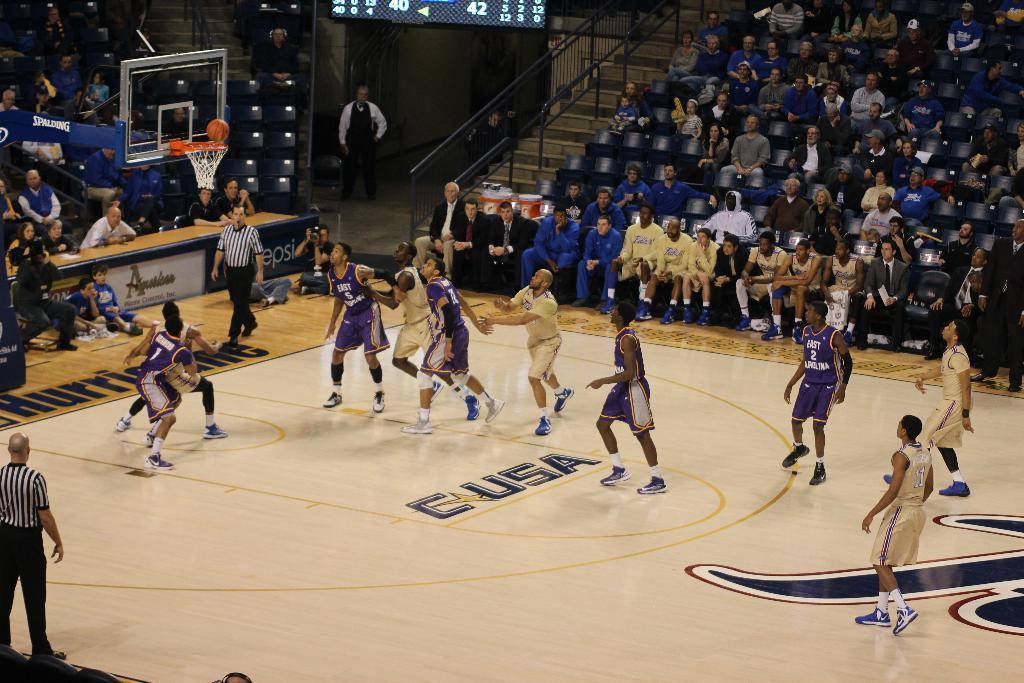In one or two sentences, can you explain what this image depicts? In this picture we can see group of people, few are seated on the chairs, few are standing and few people playing game, in the top left hand corner we can see a ball and net, at the top of the image we can see a digital screen. 